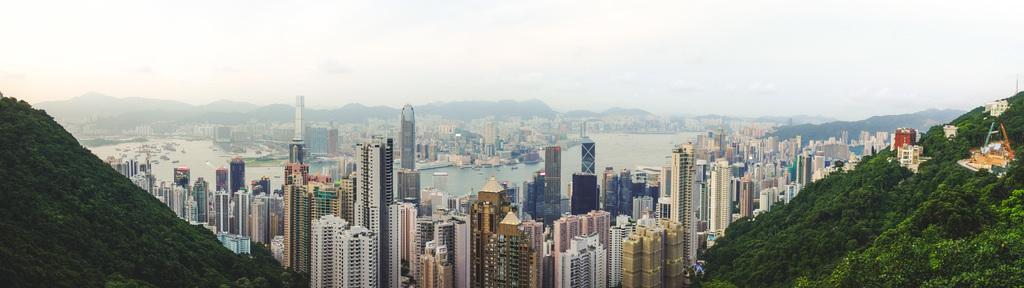In one or two sentences, can you explain what this image depicts? There is an aerial view in the image, where we can see buildings, greenery, water, mountains and sky. 